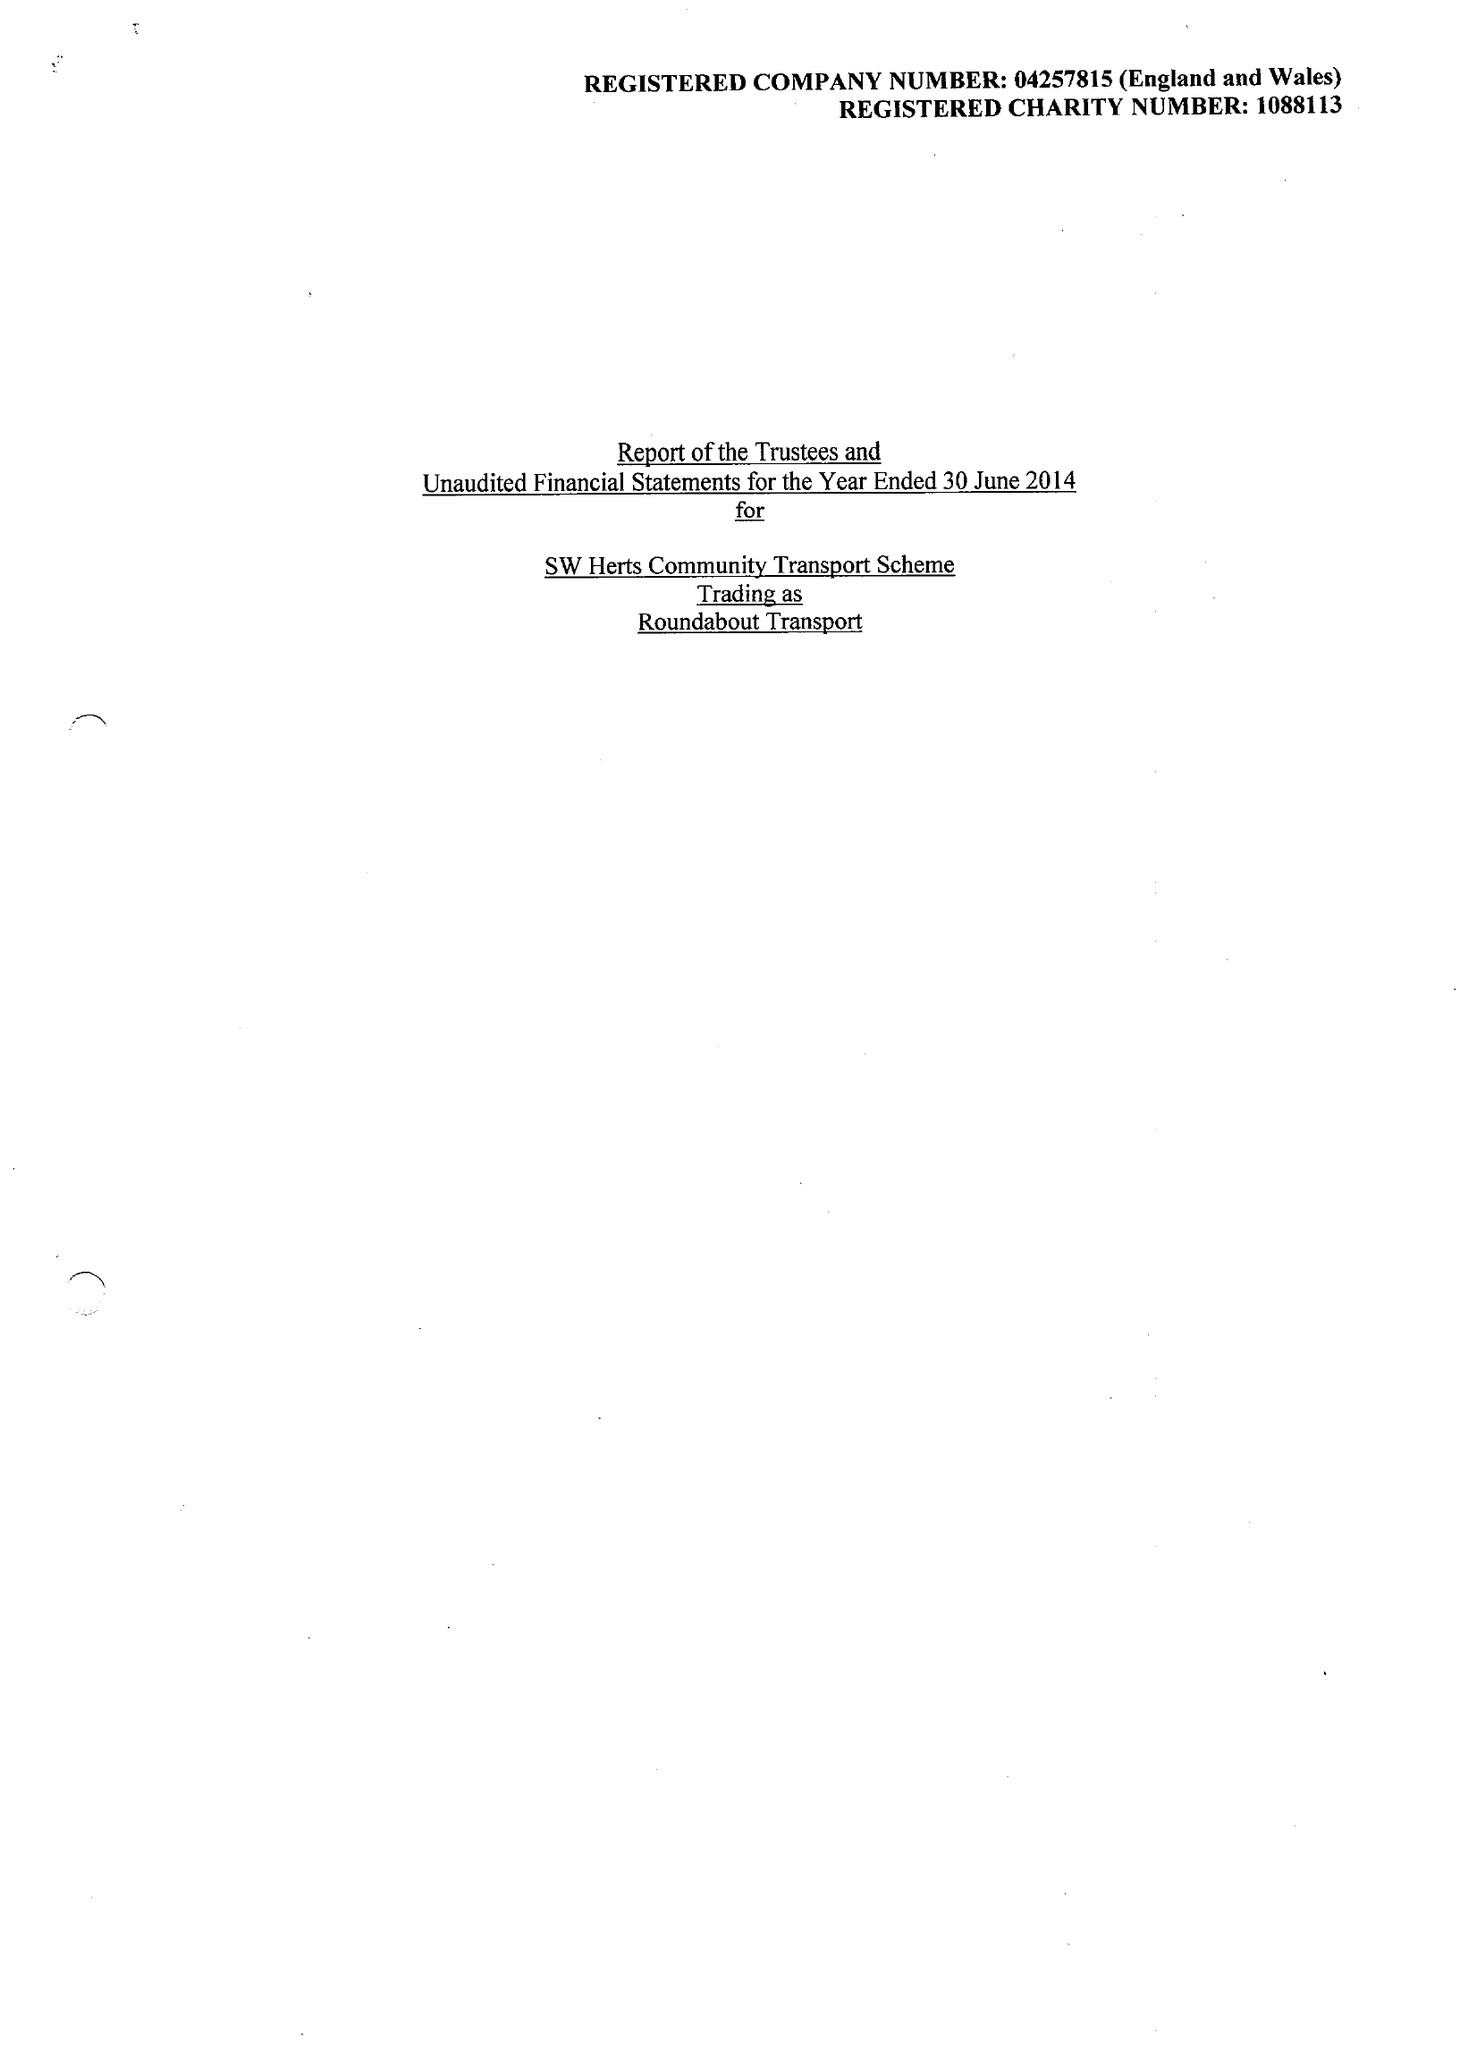What is the value for the address__street_line?
Answer the question using a single word or phrase. BURY LANE 